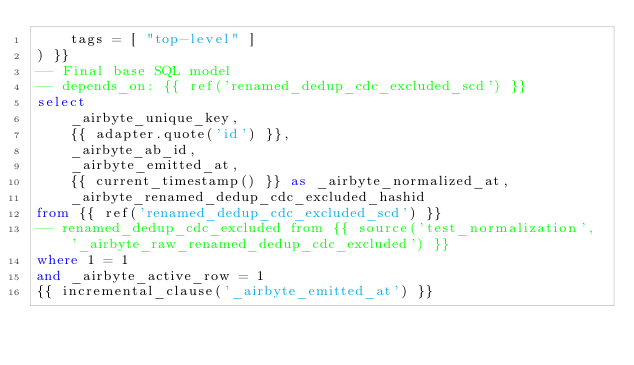Convert code to text. <code><loc_0><loc_0><loc_500><loc_500><_SQL_>    tags = [ "top-level" ]
) }}
-- Final base SQL model
-- depends_on: {{ ref('renamed_dedup_cdc_excluded_scd') }}
select
    _airbyte_unique_key,
    {{ adapter.quote('id') }},
    _airbyte_ab_id,
    _airbyte_emitted_at,
    {{ current_timestamp() }} as _airbyte_normalized_at,
    _airbyte_renamed_dedup_cdc_excluded_hashid
from {{ ref('renamed_dedup_cdc_excluded_scd') }}
-- renamed_dedup_cdc_excluded from {{ source('test_normalization', '_airbyte_raw_renamed_dedup_cdc_excluded') }}
where 1 = 1
and _airbyte_active_row = 1
{{ incremental_clause('_airbyte_emitted_at') }}

</code> 